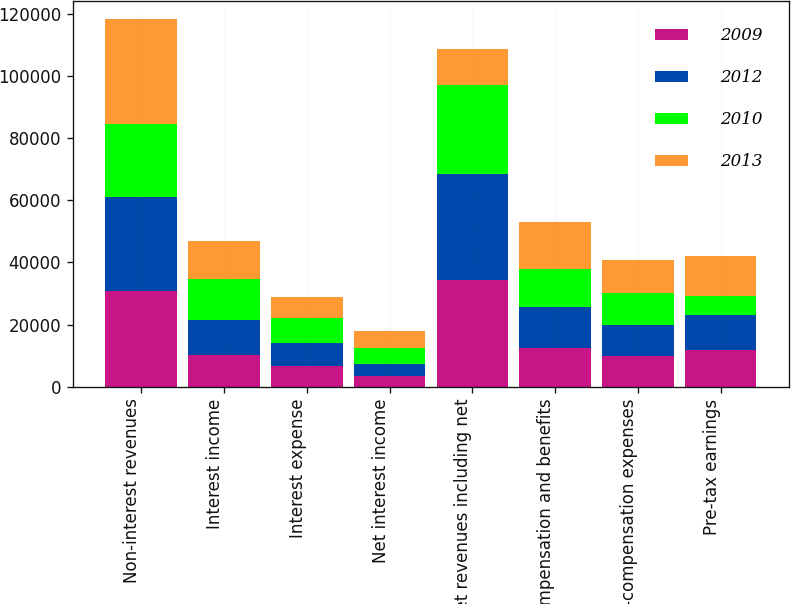Convert chart. <chart><loc_0><loc_0><loc_500><loc_500><stacked_bar_chart><ecel><fcel>Non-interest revenues<fcel>Interest income<fcel>Interest expense<fcel>Net interest income<fcel>Net revenues including net<fcel>Compensation and benefits<fcel>Non-compensation expenses<fcel>Pre-tax earnings<nl><fcel>2009<fcel>30814<fcel>10060<fcel>6668<fcel>3392<fcel>34206<fcel>12613<fcel>9856<fcel>11737<nl><fcel>2012<fcel>30283<fcel>11381<fcel>7501<fcel>3880<fcel>34163<fcel>12944<fcel>10012<fcel>11207<nl><fcel>2010<fcel>23619<fcel>13174<fcel>7982<fcel>5192<fcel>28811<fcel>12223<fcel>10419<fcel>6169<nl><fcel>2013<fcel>33658<fcel>12309<fcel>6806<fcel>5503<fcel>11381<fcel>15376<fcel>10428<fcel>12892<nl></chart> 